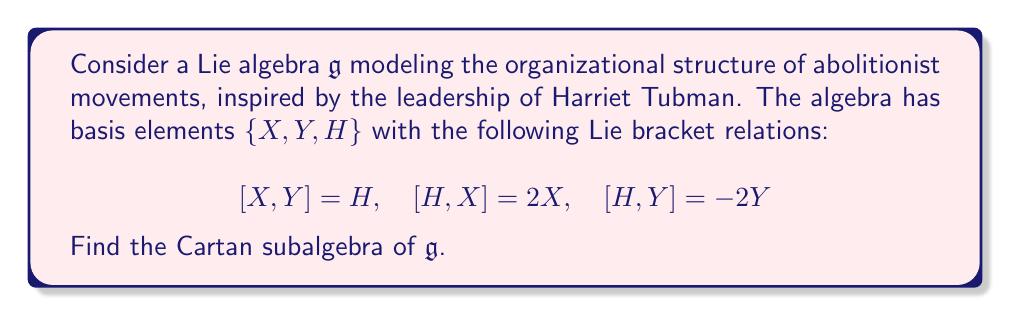Can you answer this question? To find the Cartan subalgebra of $\mathfrak{g}$, we need to identify the maximal abelian subalgebra consisting of semisimple elements. Let's approach this step-by-step:

1) First, recall that a Cartan subalgebra is a maximal self-normalizing subalgebra of $\mathfrak{g}$ consisting of semisimple elements.

2) We need to check which elements commute with all other elements in their span. Let's consider a general element $aX + bY + cH$ where $a,b,c \in \mathbb{R}$.

3) For this to be in the Cartan subalgebra, it must commute with itself and any other element in its span. Let's compute some brackets:

   $[aX + bY + cH, X] = acH - 2cX$
   $[aX + bY + cH, Y] = -acH + 2cY$
   $[aX + bY + cH, H] = 2aX - 2bY$

4) For these to be zero, we must have $a=b=0$ and $c$ can be any real number.

5) Therefore, the Cartan subalgebra is spanned by $H$.

6) We can verify that $H$ is indeed semisimple by considering its adjoint action on $\mathfrak{g}$:

   $ad_H(X) = [H,X] = 2X$
   $ad_H(Y) = [H,Y] = -2Y$
   $ad_H(H) = [H,H] = 0$

   The matrix of $ad_H$ in the basis $\{X,Y,H\}$ is:

   $$ad_H = \begin{pmatrix}
   2 & 0 & 0 \\
   0 & -2 & 0 \\
   0 & 0 & 0
   \end{pmatrix}$$

   This matrix is diagonalizable, confirming that $H$ is semisimple.

7) Thus, the one-dimensional subalgebra spanned by $H$ is the Cartan subalgebra of $\mathfrak{g}$.

This structure is reminiscent of how Harriet Tubman, as a central figure, coordinated and balanced the various elements of the abolitionist movement, much like how $H$ relates to $X$ and $Y$ in the algebra.
Answer: The Cartan subalgebra of $\mathfrak{g}$ is $\mathfrak{h} = \text{span}\{H\}$. 